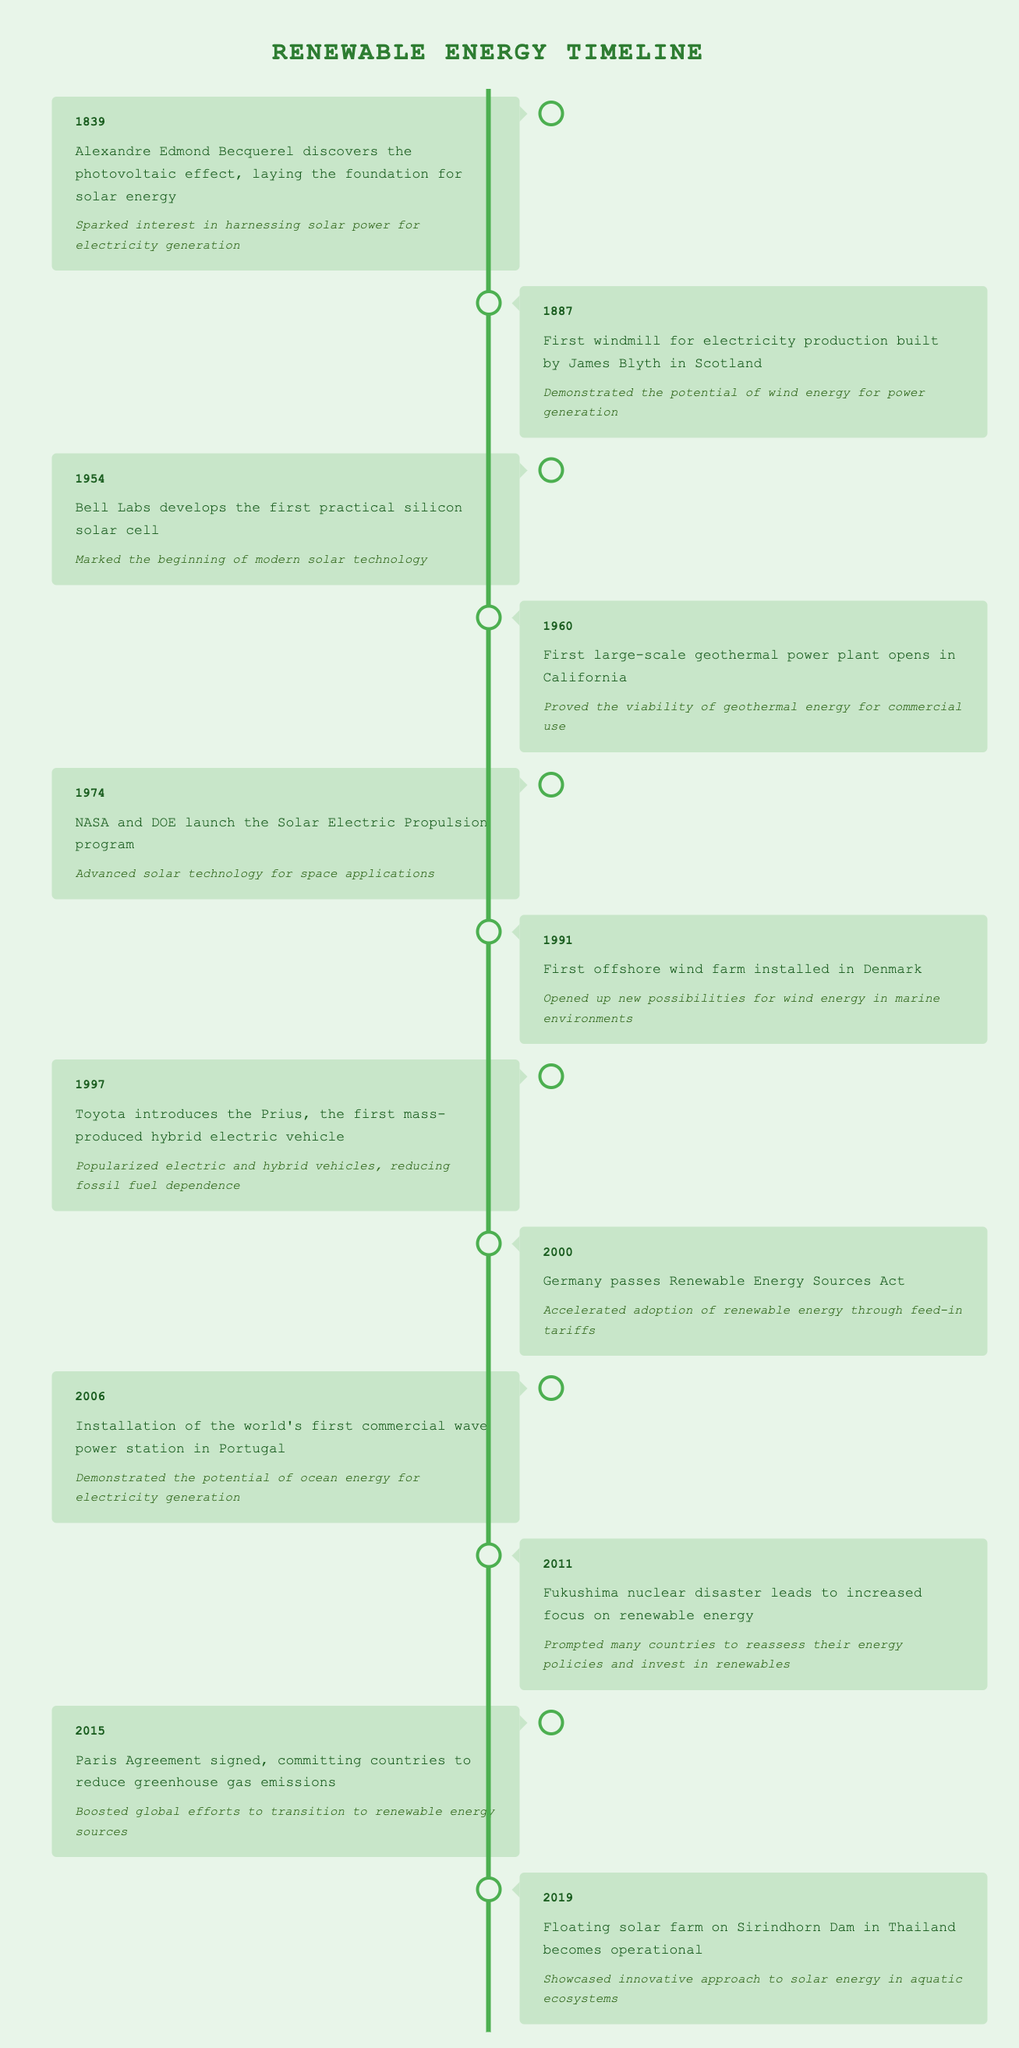What year did Becquerel discover the photovoltaic effect? From the timeline, the event linked to the discovery of the photovoltaic effect is listed for the year 1839.
Answer: 1839 What impact did the first large-scale geothermal power plant have? The timeline states that the opening of the first large-scale geothermal power plant in California in 1960 proved the viability of geothermal energy for commercial use.
Answer: It proved the viability of geothermal energy for commercial use How many years were there between the installation of the first windmill and the introduction of the Prius? The first windmill was built in 1887 and the Prius was introduced in 1997. The difference between these years is 1997 - 1887 = 110 years.
Answer: 110 years Did the installation of the world's first commercial wave power station occur before the passing of the Renewable Energy Sources Act in Germany? The timeline shows the wave power station was installed in 2006, while the Renewable Energy Sources Act was passed in 2000. Since 2006 is after 2000, the statement is false.
Answer: No Which renewable energy event occurred closest to the Paris Agreement signing? The Paris Agreement was signed in 2015, and the most recent event before that was the floating solar farm becoming operational in 2019. Since 2019 comes after 2015, the last event should have been the Fukushima disaster in 2011. Thus, the events before 2015 are 2011 (Fukushima) and 2019 (floating solar farm). The Fukushima event occurred closest to the Paris Agreement signing in 2015.
Answer: Fukushima disaster in 2011 occurred closest to the Paris Agreement signing 